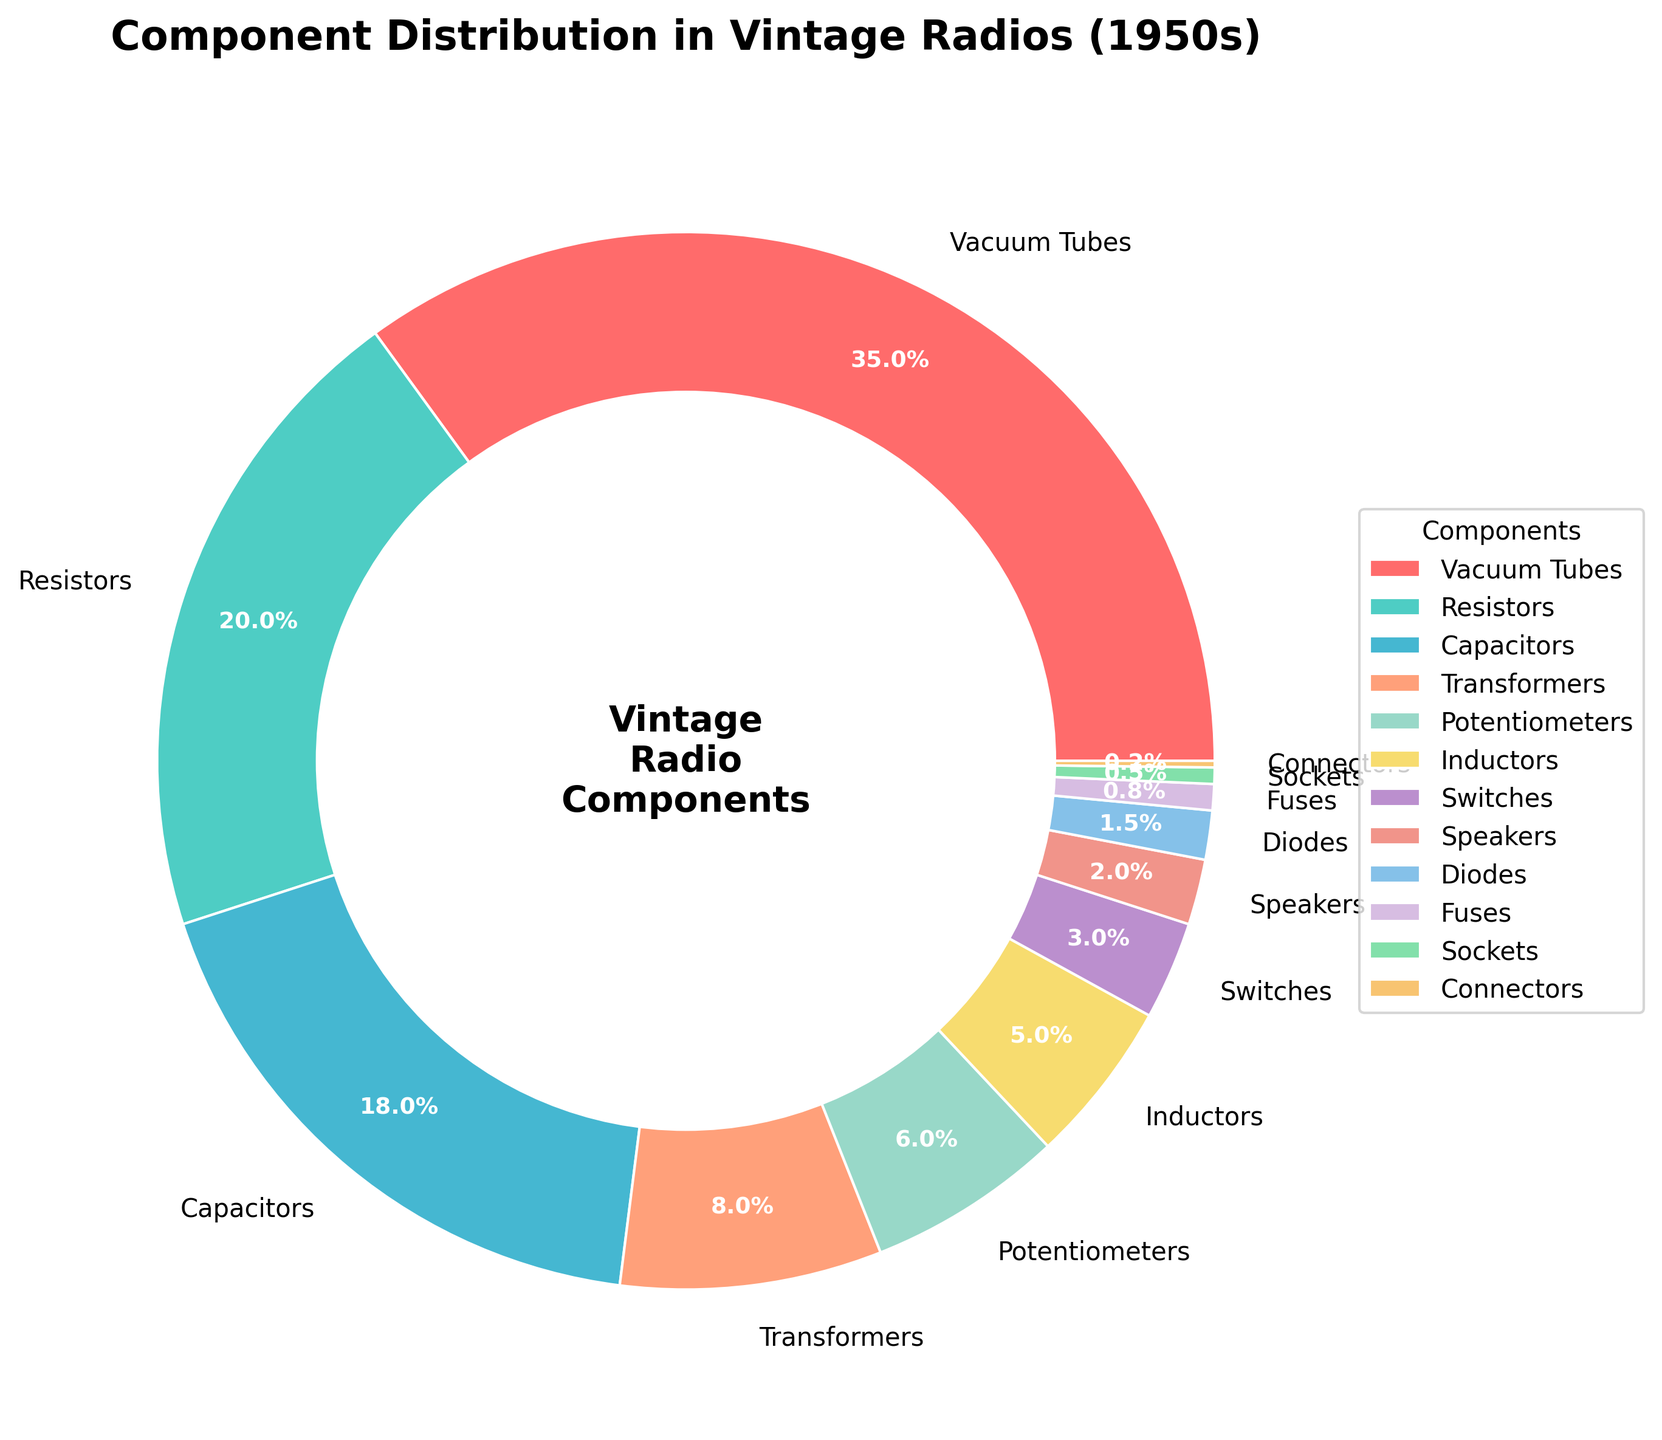What component has the largest percentage in the distribution? The figure shows various components with different percentages. The one with the largest percentage is Vacuum Tubes at 35%.
Answer: Vacuum Tubes Which two components together make up more than half of the total distribution? Adding the percentages of Vacuum Tubes (35%) and Resistors (20%) gives 35 + 20 = 55%, which is more than half of the distribution.
Answer: Vacuum Tubes and Resistors How many components have a percentage less than 5%? By looking at the pie chart, we identify components with percentages less than 5%: Inductors (5%), Switches (3%), Speakers (2%), Diodes (1.5%), Fuses (0.8%), Sockets (0.5%), Connectors (0.2%). Counting these components, there are 7.
Answer: 7 What is the visual color of the segment representing Capacitors in the pie chart? By referring to the pie chart, we see that Capacitors have a specific color. The color is a shade of blue.
Answer: Blue Compare the percentage of Transformers and Potentiometers. Which has a higher percentage and by how much? Transformers have a percentage of 8% and Potentiometers have 6%. The difference is 8 - 6 = 2%.
Answer: Transformers by 2% What percentage of the total distribution is made up of Switches and Diodes combined? Adding the percentages of Switches (3%) and Diodes (1.5%) gives 3 + 1.5 = 4.5%.
Answer: 4.5% Is the percentage of Resistors greater than the combined percentage of Speakers and Sockets? Resistors have a percentage of 20%, whereas Speakers (2%) and Sockets (0.5%) together have 2 + 0.5 = 2.5%. Therefore, 20% is greater than 2.5%.
Answer: Yes Which component has the smallest percentage and what is it? The chart shows the smallest percentage belongs to Connectors at 0.2%.
Answer: Connectors, 0.2% What is the combined percentage of all components that fall under 1%? Components under 1% are Diodes (1.5%), Fuses (0.8%), Sockets (0.5%), and Connectors (0.2%). Adding them gives 1.5 + 0.8 + 0.5 + 0.2 = 3%.
Answer: 3% Which component section is visually the largest and what is its color? The largest section is for Vacuum Tubes, and it is visually represented with a red-like color.
Answer: Vacuum Tubes, red 